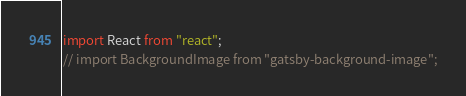<code> <loc_0><loc_0><loc_500><loc_500><_JavaScript_>import React from "react";
// import BackgroundImage from "gatsby-background-image";

</code> 